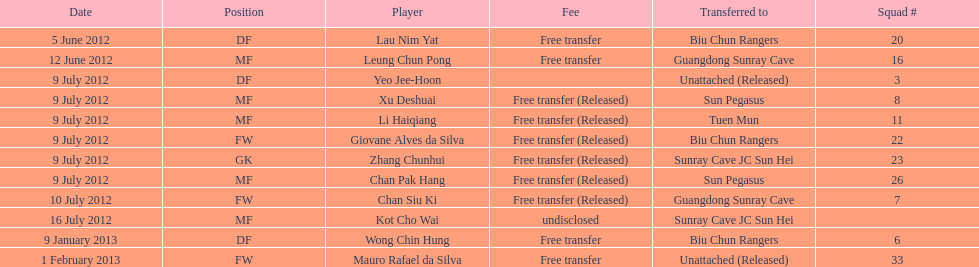What squad # is listed previous to squad # 7? 26. 